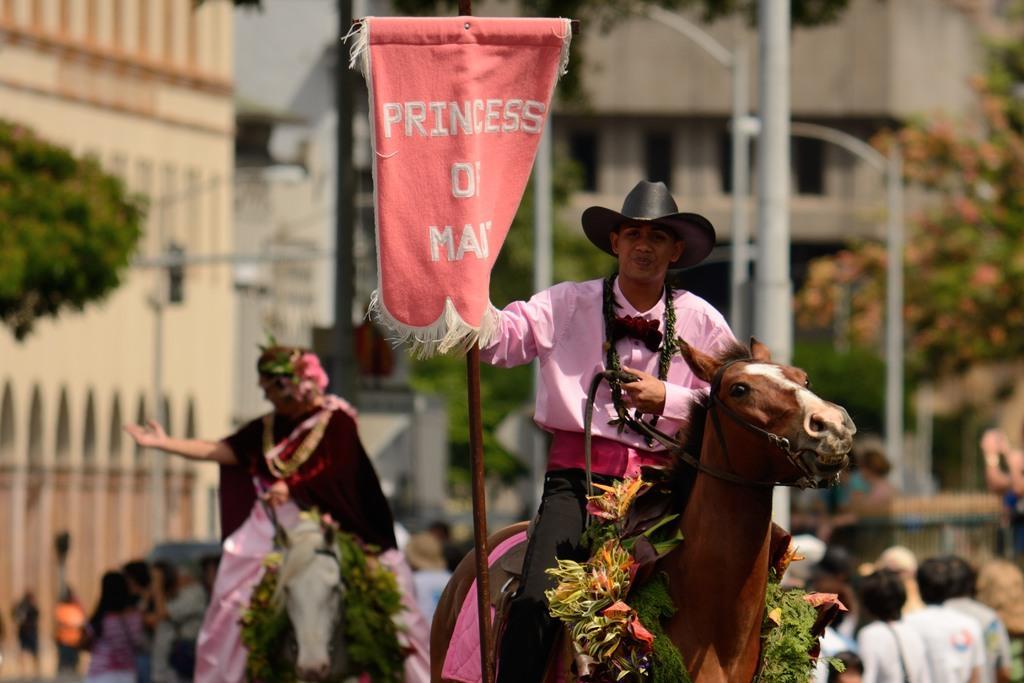Describe this image in one or two sentences. In this image, In the right side there is a man sitting on a horse which is in brown color and he is riding a horse and he is holding a red color flag on that princess of man is written, In the left side there is a woman sitting, in the background there are some people walking and there is a pole which is in white color. 